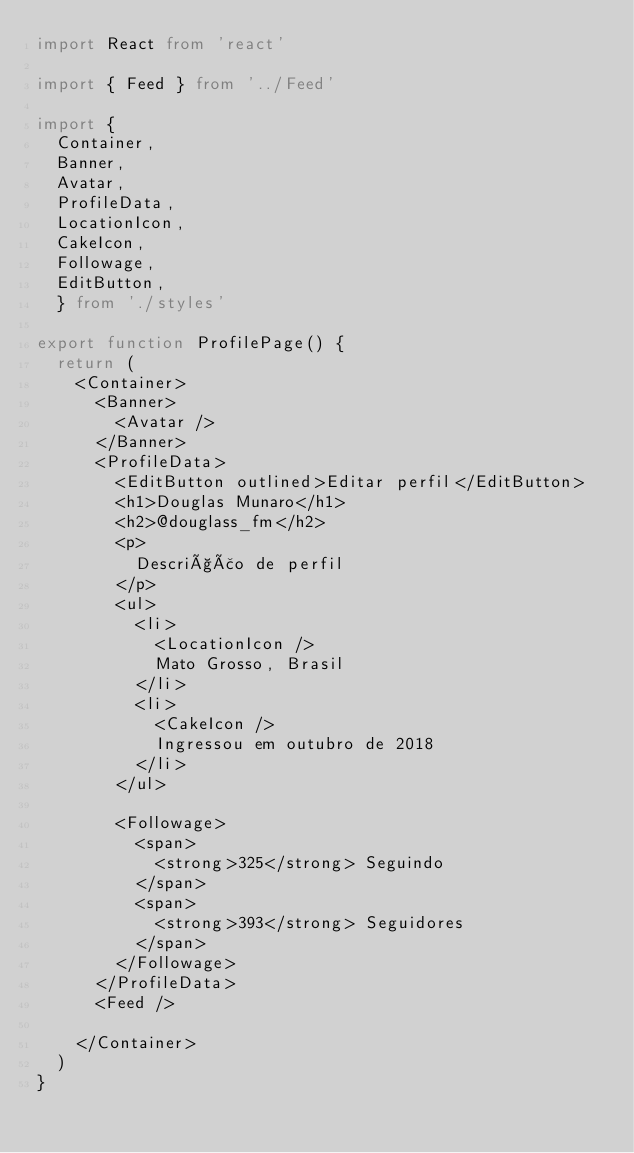<code> <loc_0><loc_0><loc_500><loc_500><_TypeScript_>import React from 'react'

import { Feed } from '../Feed'

import { 
  Container,
  Banner, 
  Avatar,
  ProfileData,
  LocationIcon,
  CakeIcon,
  Followage,
  EditButton,
  } from './styles'

export function ProfilePage() {
  return (
    <Container>
      <Banner>
        <Avatar />
      </Banner>
      <ProfileData>
        <EditButton outlined>Editar perfil</EditButton>
        <h1>Douglas Munaro</h1>
        <h2>@douglass_fm</h2>
        <p>
          Descrição de perfil
        </p>
        <ul>
          <li>
            <LocationIcon />
            Mato Grosso, Brasil
          </li>
          <li>
            <CakeIcon />
            Ingressou em outubro de 2018
          </li>
        </ul>
      
        <Followage>
          <span>
            <strong>325</strong> Seguindo
          </span>
          <span>
            <strong>393</strong> Seguidores
          </span>
        </Followage>
      </ProfileData>
      <Feed />

    </Container>
  )
}</code> 